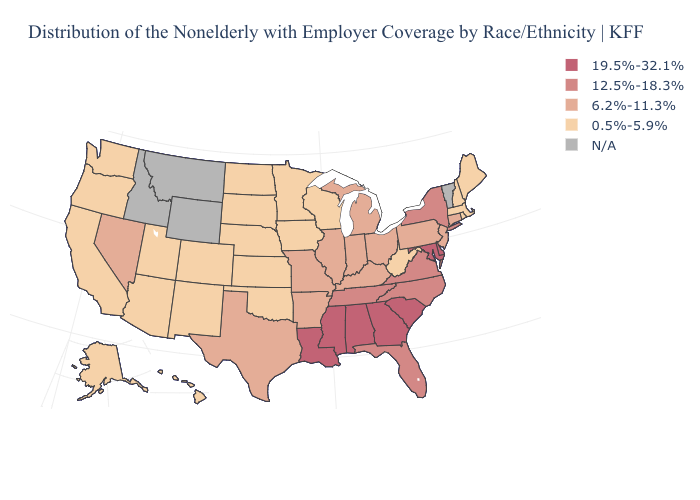Among the states that border Massachusetts , does New Hampshire have the highest value?
Give a very brief answer. No. Name the states that have a value in the range 19.5%-32.1%?
Short answer required. Alabama, Delaware, Georgia, Louisiana, Maryland, Mississippi, South Carolina. Does the first symbol in the legend represent the smallest category?
Concise answer only. No. What is the value of North Dakota?
Concise answer only. 0.5%-5.9%. What is the value of Maryland?
Be succinct. 19.5%-32.1%. How many symbols are there in the legend?
Write a very short answer. 5. What is the value of West Virginia?
Keep it brief. 0.5%-5.9%. What is the value of Ohio?
Give a very brief answer. 6.2%-11.3%. Does New Hampshire have the lowest value in the USA?
Short answer required. Yes. What is the value of New Hampshire?
Be succinct. 0.5%-5.9%. What is the value of New Hampshire?
Be succinct. 0.5%-5.9%. What is the value of North Carolina?
Write a very short answer. 12.5%-18.3%. What is the highest value in the Northeast ?
Quick response, please. 12.5%-18.3%. Among the states that border Arkansas , which have the highest value?
Short answer required. Louisiana, Mississippi. Does the first symbol in the legend represent the smallest category?
Give a very brief answer. No. 